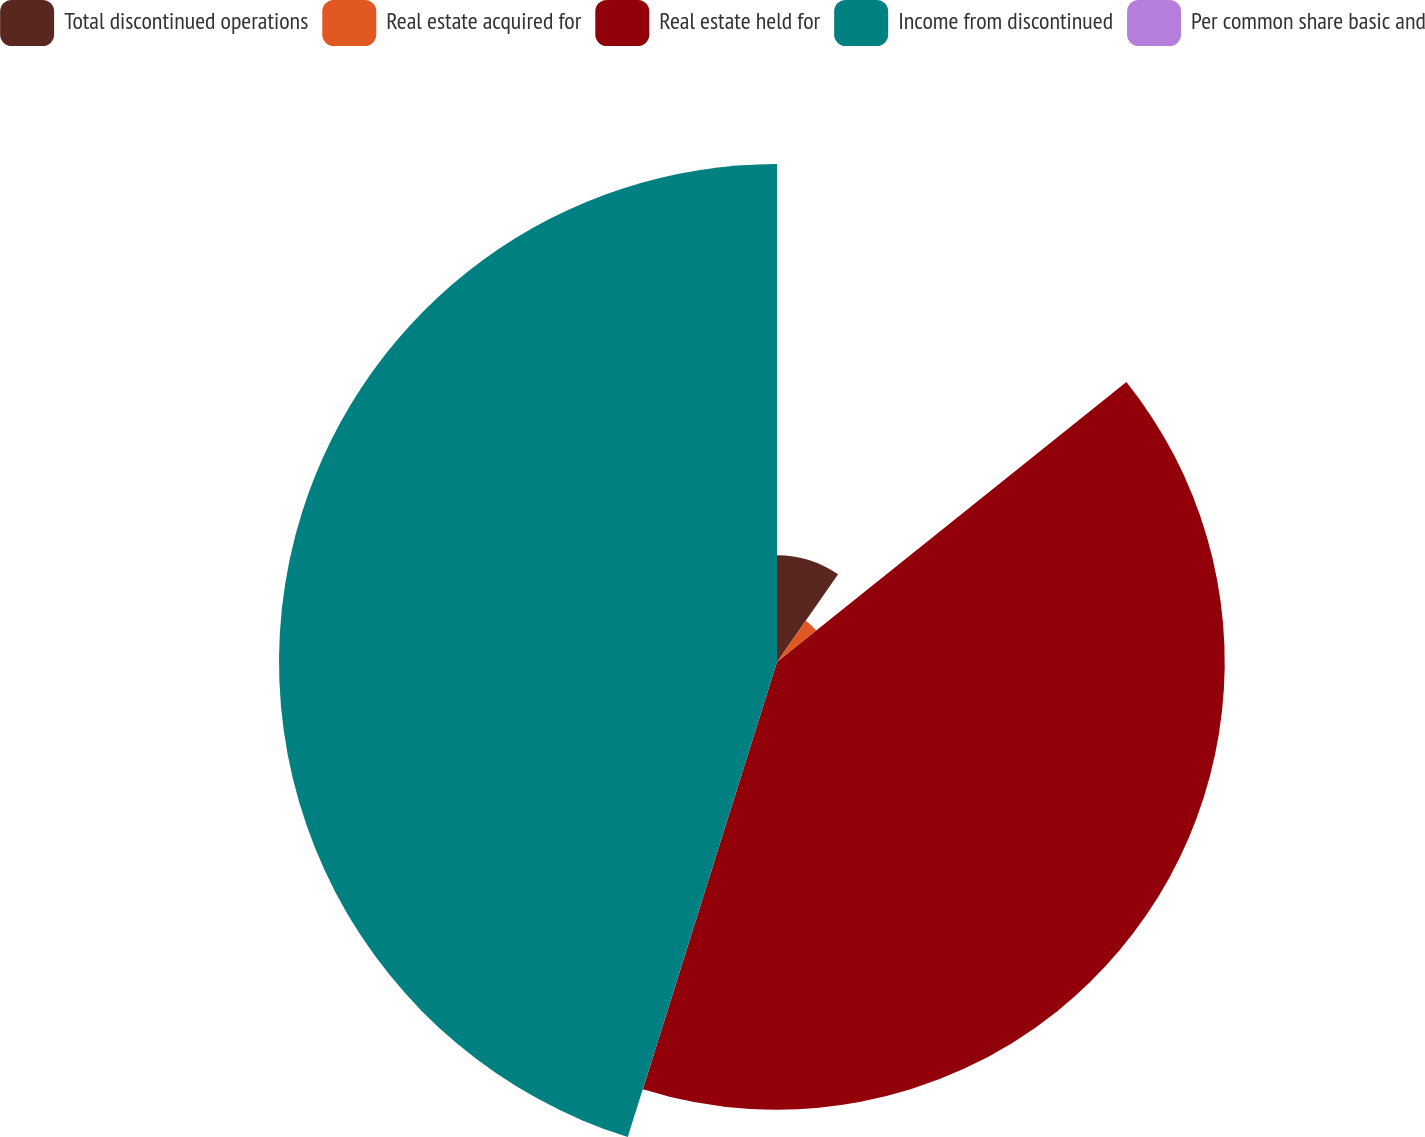Convert chart. <chart><loc_0><loc_0><loc_500><loc_500><pie_chart><fcel>Total discontinued operations<fcel>Real estate acquired for<fcel>Real estate held for<fcel>Income from discontinued<fcel>Per common share basic and<nl><fcel>9.69%<fcel>4.56%<fcel>40.6%<fcel>45.16%<fcel>0.0%<nl></chart> 